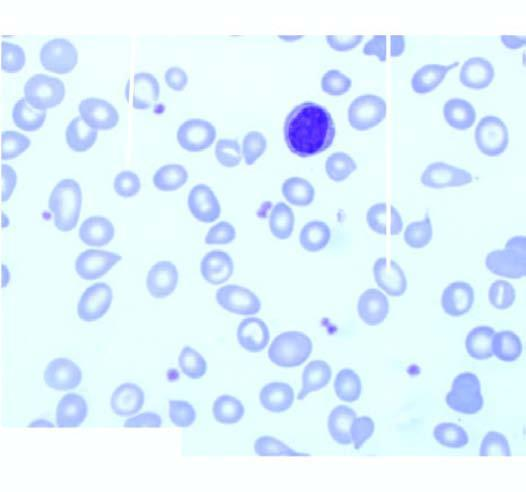s there moderate microcytosis and hypochromia?
Answer the question using a single word or phrase. Yes 